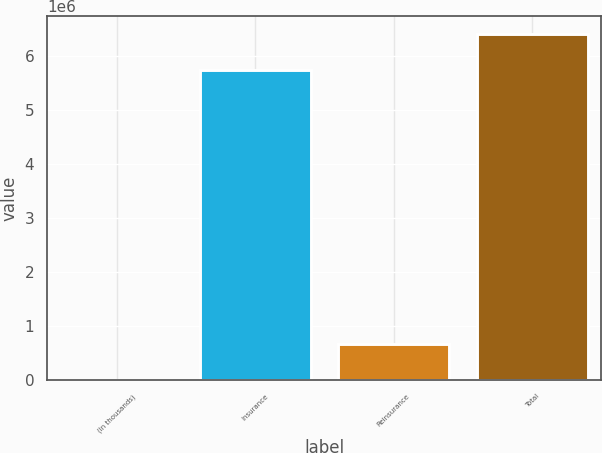Convert chart. <chart><loc_0><loc_0><loc_500><loc_500><bar_chart><fcel>(In thousands)<fcel>Insurance<fcel>Reinsurance<fcel>Total<nl><fcel>2016<fcel>5.74362e+06<fcel>680293<fcel>6.42391e+06<nl></chart> 